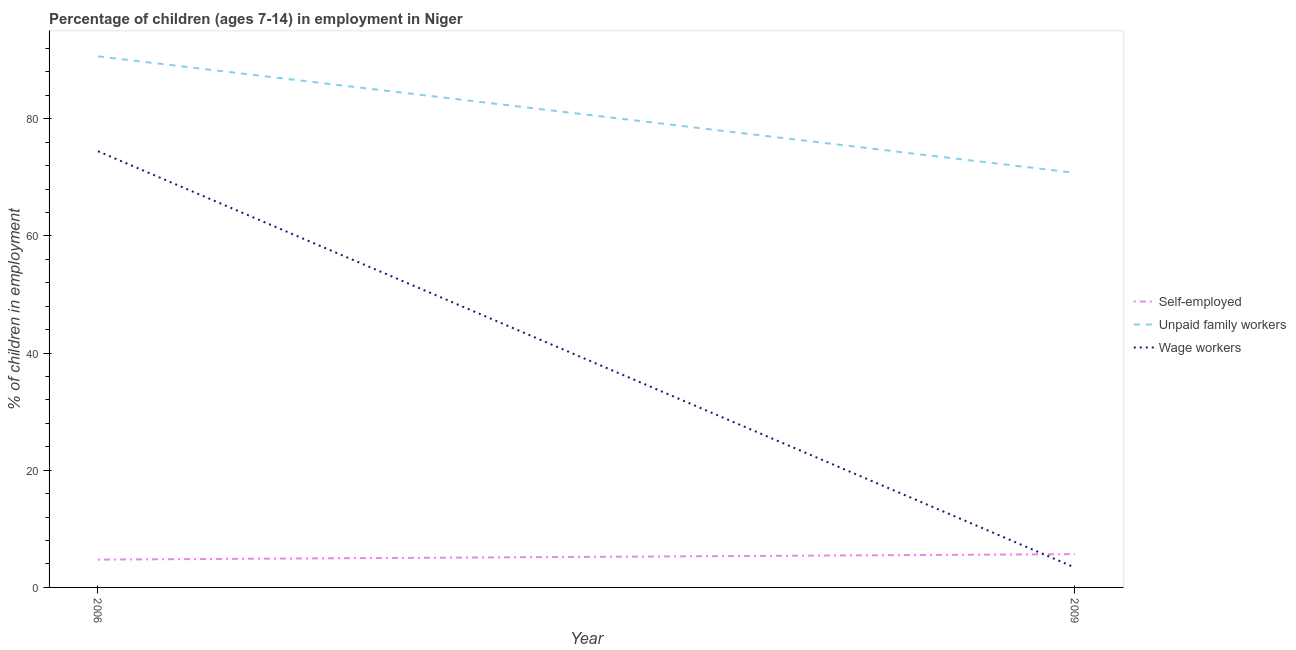Does the line corresponding to percentage of self employed children intersect with the line corresponding to percentage of children employed as unpaid family workers?
Offer a terse response. No. Is the number of lines equal to the number of legend labels?
Make the answer very short. Yes. What is the percentage of children employed as unpaid family workers in 2006?
Provide a short and direct response. 90.66. Across all years, what is the maximum percentage of children employed as unpaid family workers?
Your response must be concise. 90.66. Across all years, what is the minimum percentage of children employed as wage workers?
Your response must be concise. 3.39. In which year was the percentage of self employed children minimum?
Offer a very short reply. 2006. What is the total percentage of self employed children in the graph?
Give a very brief answer. 10.43. What is the difference between the percentage of children employed as unpaid family workers in 2006 and that in 2009?
Offer a terse response. 19.88. What is the difference between the percentage of self employed children in 2006 and the percentage of children employed as unpaid family workers in 2009?
Ensure brevity in your answer.  -66.03. What is the average percentage of children employed as unpaid family workers per year?
Provide a succinct answer. 80.72. In the year 2009, what is the difference between the percentage of children employed as unpaid family workers and percentage of children employed as wage workers?
Give a very brief answer. 67.39. What is the ratio of the percentage of children employed as wage workers in 2006 to that in 2009?
Ensure brevity in your answer.  21.97. Is the percentage of children employed as wage workers in 2006 less than that in 2009?
Give a very brief answer. No. Is the percentage of self employed children strictly greater than the percentage of children employed as unpaid family workers over the years?
Ensure brevity in your answer.  No. How many lines are there?
Offer a very short reply. 3. What is the difference between two consecutive major ticks on the Y-axis?
Provide a short and direct response. 20. Where does the legend appear in the graph?
Your response must be concise. Center right. How are the legend labels stacked?
Provide a short and direct response. Vertical. What is the title of the graph?
Ensure brevity in your answer.  Percentage of children (ages 7-14) in employment in Niger. What is the label or title of the Y-axis?
Provide a short and direct response. % of children in employment. What is the % of children in employment of Self-employed in 2006?
Offer a terse response. 4.75. What is the % of children in employment of Unpaid family workers in 2006?
Make the answer very short. 90.66. What is the % of children in employment of Wage workers in 2006?
Keep it short and to the point. 74.47. What is the % of children in employment in Self-employed in 2009?
Ensure brevity in your answer.  5.68. What is the % of children in employment in Unpaid family workers in 2009?
Provide a short and direct response. 70.78. What is the % of children in employment of Wage workers in 2009?
Offer a very short reply. 3.39. Across all years, what is the maximum % of children in employment of Self-employed?
Your answer should be compact. 5.68. Across all years, what is the maximum % of children in employment in Unpaid family workers?
Provide a succinct answer. 90.66. Across all years, what is the maximum % of children in employment in Wage workers?
Your answer should be very brief. 74.47. Across all years, what is the minimum % of children in employment of Self-employed?
Your answer should be very brief. 4.75. Across all years, what is the minimum % of children in employment of Unpaid family workers?
Your response must be concise. 70.78. Across all years, what is the minimum % of children in employment in Wage workers?
Make the answer very short. 3.39. What is the total % of children in employment in Self-employed in the graph?
Keep it short and to the point. 10.43. What is the total % of children in employment in Unpaid family workers in the graph?
Ensure brevity in your answer.  161.44. What is the total % of children in employment of Wage workers in the graph?
Offer a very short reply. 77.86. What is the difference between the % of children in employment in Self-employed in 2006 and that in 2009?
Your response must be concise. -0.93. What is the difference between the % of children in employment of Unpaid family workers in 2006 and that in 2009?
Offer a very short reply. 19.88. What is the difference between the % of children in employment in Wage workers in 2006 and that in 2009?
Keep it short and to the point. 71.08. What is the difference between the % of children in employment of Self-employed in 2006 and the % of children in employment of Unpaid family workers in 2009?
Your answer should be compact. -66.03. What is the difference between the % of children in employment in Self-employed in 2006 and the % of children in employment in Wage workers in 2009?
Give a very brief answer. 1.36. What is the difference between the % of children in employment of Unpaid family workers in 2006 and the % of children in employment of Wage workers in 2009?
Offer a very short reply. 87.27. What is the average % of children in employment in Self-employed per year?
Keep it short and to the point. 5.21. What is the average % of children in employment in Unpaid family workers per year?
Your response must be concise. 80.72. What is the average % of children in employment in Wage workers per year?
Your response must be concise. 38.93. In the year 2006, what is the difference between the % of children in employment in Self-employed and % of children in employment in Unpaid family workers?
Provide a short and direct response. -85.91. In the year 2006, what is the difference between the % of children in employment in Self-employed and % of children in employment in Wage workers?
Provide a succinct answer. -69.72. In the year 2006, what is the difference between the % of children in employment of Unpaid family workers and % of children in employment of Wage workers?
Offer a terse response. 16.19. In the year 2009, what is the difference between the % of children in employment of Self-employed and % of children in employment of Unpaid family workers?
Ensure brevity in your answer.  -65.1. In the year 2009, what is the difference between the % of children in employment of Self-employed and % of children in employment of Wage workers?
Your answer should be very brief. 2.29. In the year 2009, what is the difference between the % of children in employment in Unpaid family workers and % of children in employment in Wage workers?
Make the answer very short. 67.39. What is the ratio of the % of children in employment of Self-employed in 2006 to that in 2009?
Your answer should be very brief. 0.84. What is the ratio of the % of children in employment of Unpaid family workers in 2006 to that in 2009?
Offer a very short reply. 1.28. What is the ratio of the % of children in employment in Wage workers in 2006 to that in 2009?
Offer a very short reply. 21.97. What is the difference between the highest and the second highest % of children in employment of Self-employed?
Provide a succinct answer. 0.93. What is the difference between the highest and the second highest % of children in employment in Unpaid family workers?
Keep it short and to the point. 19.88. What is the difference between the highest and the second highest % of children in employment of Wage workers?
Provide a succinct answer. 71.08. What is the difference between the highest and the lowest % of children in employment in Unpaid family workers?
Your response must be concise. 19.88. What is the difference between the highest and the lowest % of children in employment in Wage workers?
Make the answer very short. 71.08. 